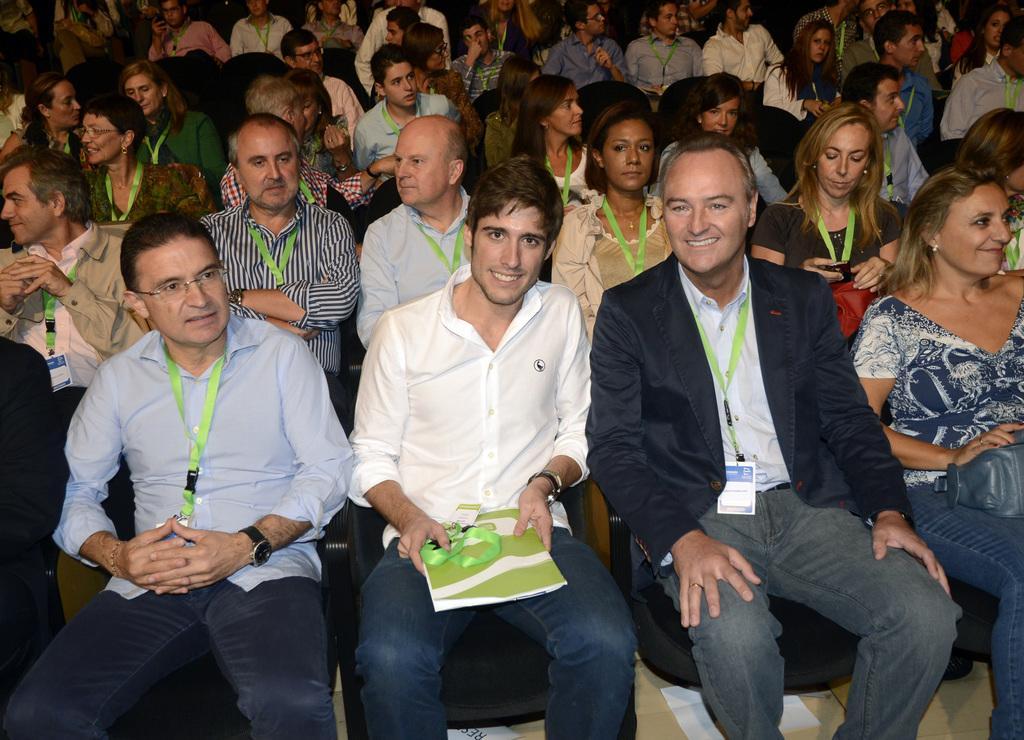Can you describe this image briefly? In this image, we can see people wearing clothes and sitting on chairs. There is a person in the middle of the image holding a book with his hands. 